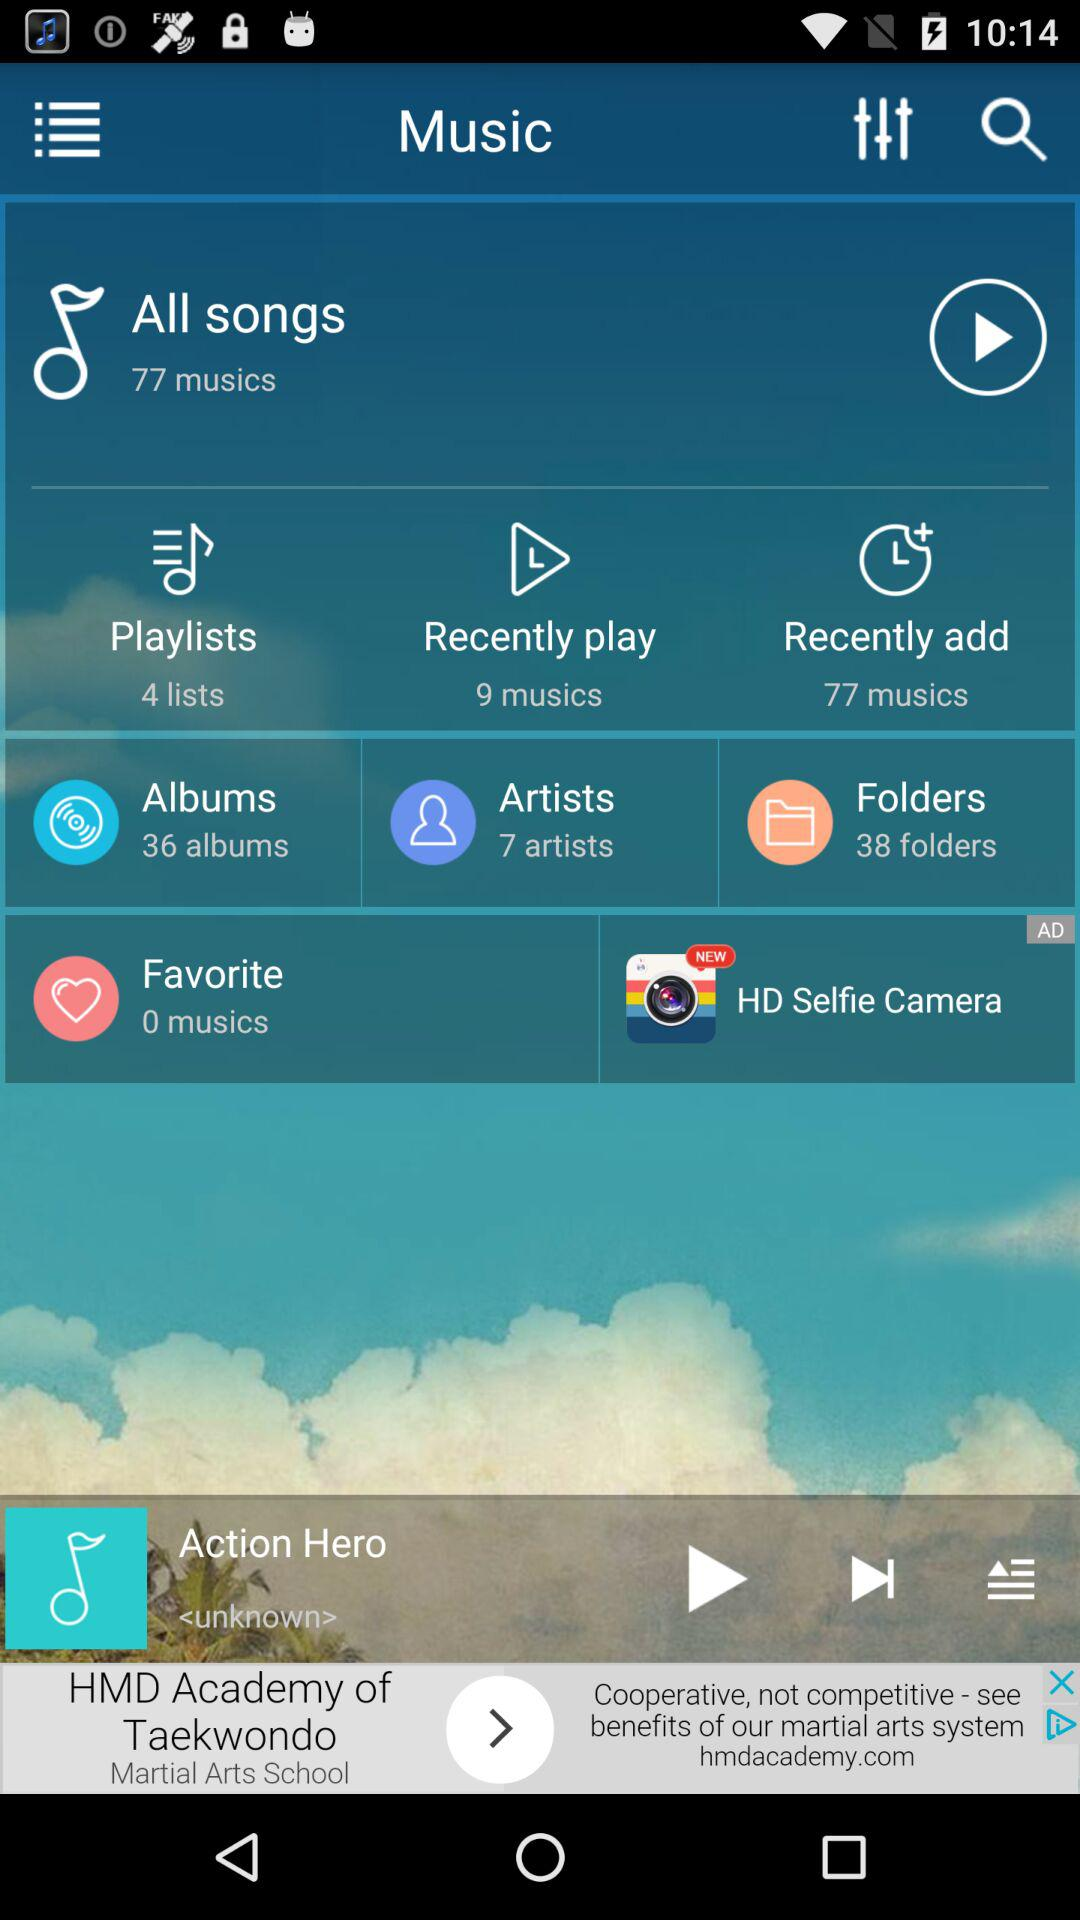What is the given number of favorites? The given number of favorites is 0. 